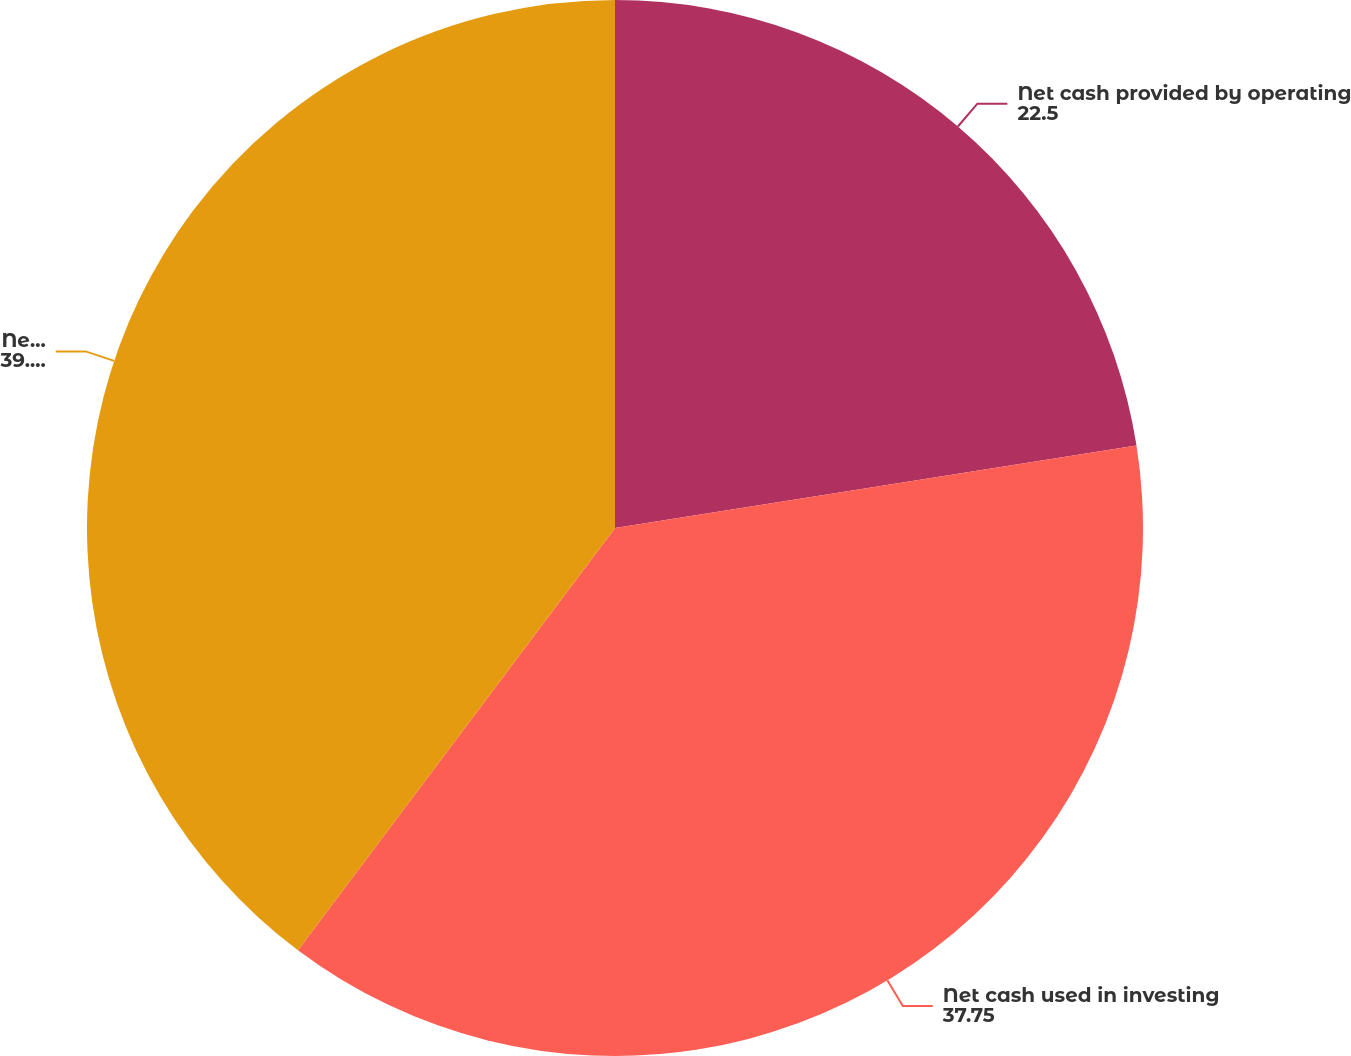Convert chart. <chart><loc_0><loc_0><loc_500><loc_500><pie_chart><fcel>Net cash provided by operating<fcel>Net cash used in investing<fcel>Net cash provided by financing<nl><fcel>22.5%<fcel>37.75%<fcel>39.75%<nl></chart> 